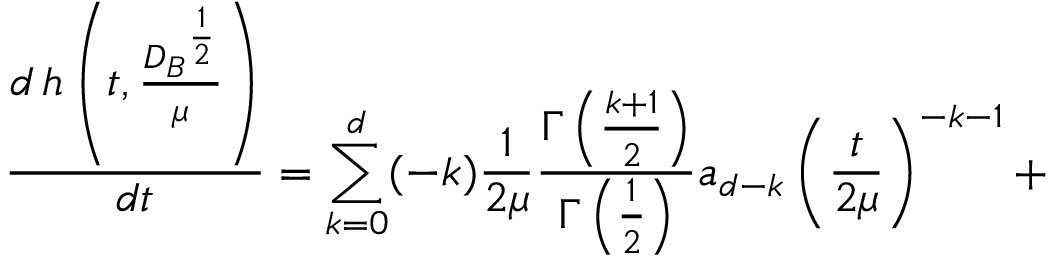Convert formula to latex. <formula><loc_0><loc_0><loc_500><loc_500>\frac { d \, h \left ( t , \frac { { D _ { B } } ^ { \frac { 1 } { 2 } } } { \mu } \right ) } { d t } = \sum _ { k = 0 } ^ { d } ( - k ) \frac { 1 } { 2 \mu } \frac { \Gamma \left ( \frac { k + 1 } 2 \right ) } { \Gamma \left ( \frac { 1 } { 2 } \right ) } a _ { d - k } \left ( \frac { t } { 2 \mu } \right ) ^ { - k - 1 } +</formula> 